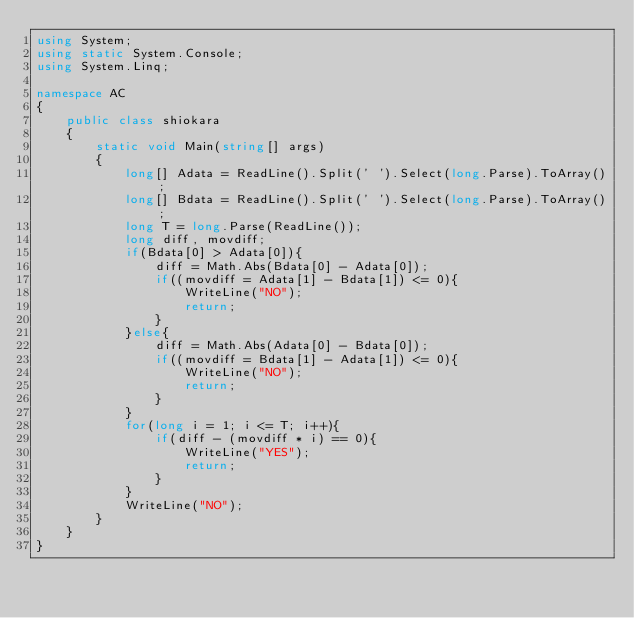Convert code to text. <code><loc_0><loc_0><loc_500><loc_500><_C#_>using System;
using static System.Console;
using System.Linq;
 
namespace AC
{
    public class shiokara
    {
        static void Main(string[] args)
        {
            long[] Adata = ReadLine().Split(' ').Select(long.Parse).ToArray();
            long[] Bdata = ReadLine().Split(' ').Select(long.Parse).ToArray();
            long T = long.Parse(ReadLine());
            long diff, movdiff;
            if(Bdata[0] > Adata[0]){
                diff = Math.Abs(Bdata[0] - Adata[0]);
                if((movdiff = Adata[1] - Bdata[1]) <= 0){
                    WriteLine("NO");
                    return;
                }
            }else{
                diff = Math.Abs(Adata[0] - Bdata[0]);
                if((movdiff = Bdata[1] - Adata[1]) <= 0){
                    WriteLine("NO");
                    return;
                }
            }
            for(long i = 1; i <= T; i++){
                if(diff - (movdiff * i) == 0){
                    WriteLine("YES");
                    return;
                }
            }
            WriteLine("NO");
        }
    }
}</code> 